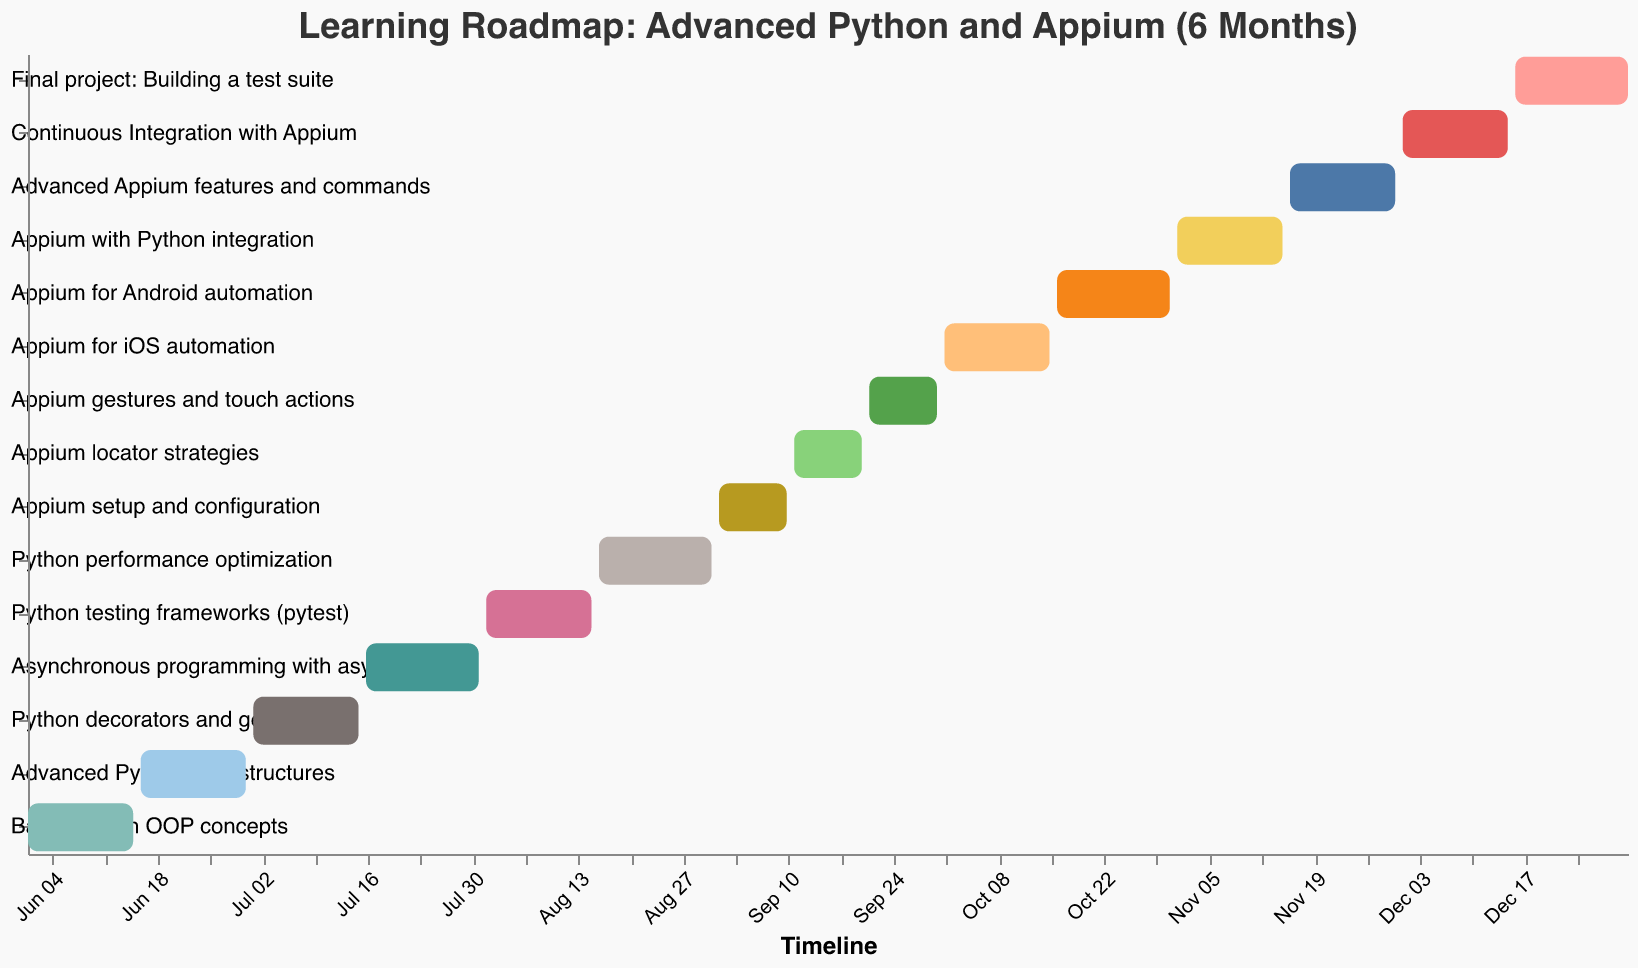What is the total duration for the task 'Advanced Python data structures'? Locate the task 'Advanced Python data structures' on the y-axis and find the 'Duration' field in the tooltip or data points.
Answer: 15 days Which task has the longest duration in the roadmap? Scan the 'Duration' field for each task and identify the one with the highest numerical value, which is 16 days. There are multiple tasks with this duration; you need to list all of them.
Answer: Asynchronous programming with asyncio, Python performance optimization, Appium for Android automation, Final project: Building a test suite How many tasks are planned for the month of October? Look at the x-axis for the timeframe spanning October 1 to October 31, and count the tasks that fall within this period.
Answer: Three tasks During which period will the 'Python testing frameworks (pytest)' task be active? Find the 'Python testing frameworks (pytest)' task on the y-axis and check its 'Start Date' and 'End Date' fields for the specific dates.
Answer: From August 1 to August 15 What's the average duration of the tasks for the month of November? Identify the tasks in November ('Appium with Python integration', 'Advanced Appium features and commands'), sum their durations, and divide by the number of tasks.
Answer: (15 + 15) / 2 = 15 days Which task is scheduled immediately after 'Appium setup and configuration' finishes? Locate 'Appium setup and configuration' on the y-axis, then find the task that starts on or after September 11.
Answer: Appium locator strategies Compare the duration of 'Appium for iOS automation' and 'Appium for Android automation'. Which one takes longer? Find both tasks on the y-axis and compare their 'Duration' fields.
Answer: Appium for Android automation What is the total number of days covered in the learning roadmap? Find the 'Start Date' of the first task and the 'End Date' of the last task, and calculate the difference in days.
Answer: 214 days (From June 1 to December 31) When does the task 'Appium gestures and touch actions' start and end? Locate 'Appium gestures and touch actions' on the y-axis and check its 'Start Date' and 'End Date' fields.
Answer: Starts on September 21 and ends on September 30 During which months will the Python-related tasks be occurring? Identify the tasks related to Python and note their corresponding months from the 'Start Date' and 'End Date' fields.
Answer: June, July, August 